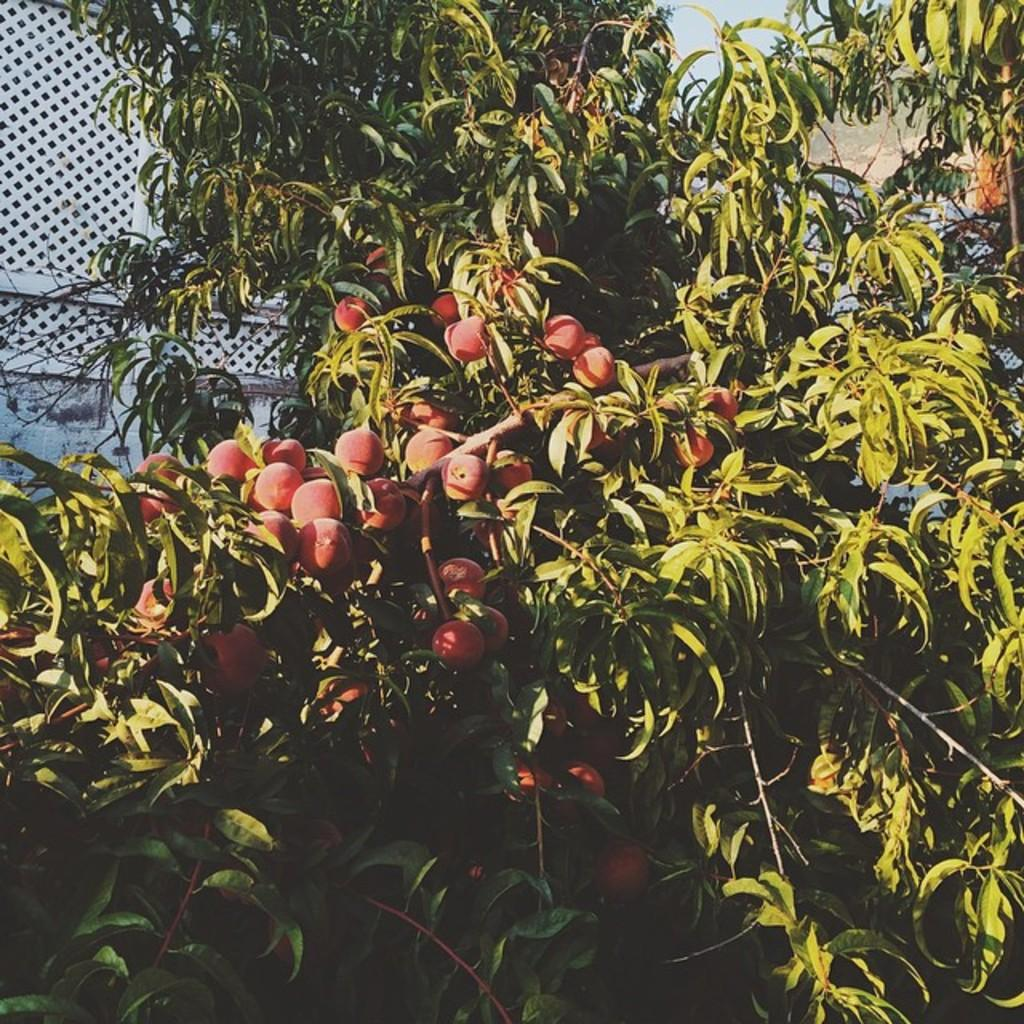What type of produce is growing on the tree in the image? There are fruits on the tree in the image. What can be seen behind the tree in the image? There is a wall in the background of the image. What part of the natural environment is visible in the image? The sky is visible in the background of the image. What type of end can be seen on the tree in the image? There is no end visible on the tree in the image; it is a living tree with fruits. 